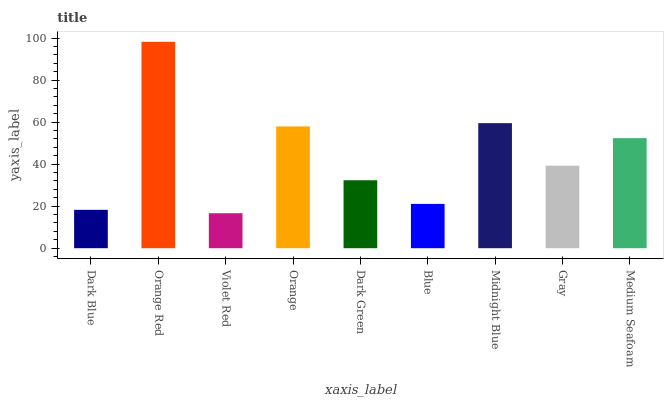Is Orange Red the minimum?
Answer yes or no. No. Is Violet Red the maximum?
Answer yes or no. No. Is Orange Red greater than Violet Red?
Answer yes or no. Yes. Is Violet Red less than Orange Red?
Answer yes or no. Yes. Is Violet Red greater than Orange Red?
Answer yes or no. No. Is Orange Red less than Violet Red?
Answer yes or no. No. Is Gray the high median?
Answer yes or no. Yes. Is Gray the low median?
Answer yes or no. Yes. Is Dark Blue the high median?
Answer yes or no. No. Is Orange the low median?
Answer yes or no. No. 